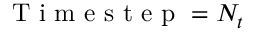<formula> <loc_0><loc_0><loc_500><loc_500>T i m e s t e p = N _ { t }</formula> 